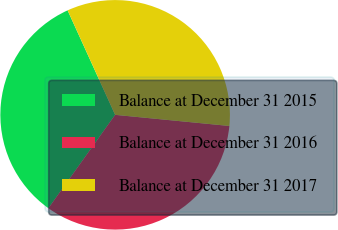Convert chart. <chart><loc_0><loc_0><loc_500><loc_500><pie_chart><fcel>Balance at December 31 2015<fcel>Balance at December 31 2016<fcel>Balance at December 31 2017<nl><fcel>33.33%<fcel>33.33%<fcel>33.34%<nl></chart> 